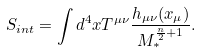<formula> <loc_0><loc_0><loc_500><loc_500>S _ { i n t } = \int d ^ { 4 } x T ^ { \mu \nu } \frac { h _ { \mu \nu } ( x _ { \mu } ) } { M _ { * } ^ { \frac { n } { 2 } + 1 } } .</formula> 